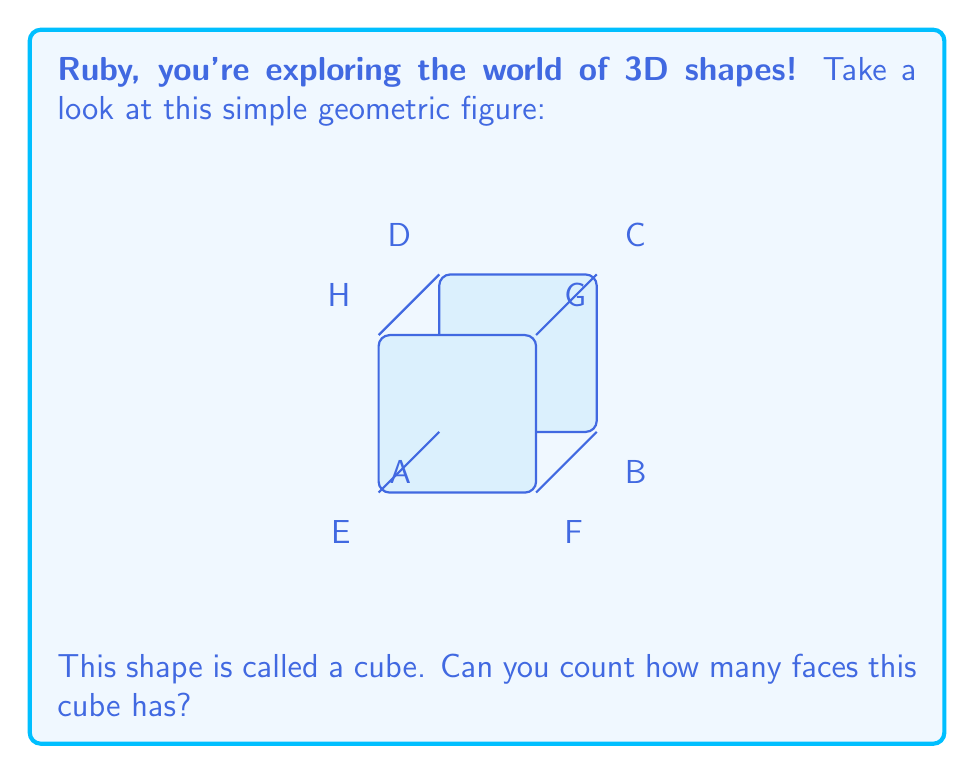Could you help me with this problem? Let's approach this step-by-step, Ruby:

1) First, let's understand what a face is. In 3D geometry, a face is a flat surface of a solid object.

2) Now, let's look at the cube from different angles:
   - From the front, we can see one square face (ABCD).
   - If we rotate the cube, we'd see another face on the back (EFGH).
   - There's a face on top (DCGH) and one on the bottom (ABFE).
   - We can also see a face on the right side (BCGF) and one on the left (ADHE).

3) Let's count these faces:
   - Front face: 1
   - Back face: 1
   - Top face: 1
   - Bottom face: 1
   - Right face: 1
   - Left face: 1

4) Adding these up: $1 + 1 + 1 + 1 + 1 + 1 = 6$

So, a cube has 6 faces in total.

Remember, Ruby, every cube has this same number of faces, regardless of its size!
Answer: 6 faces 